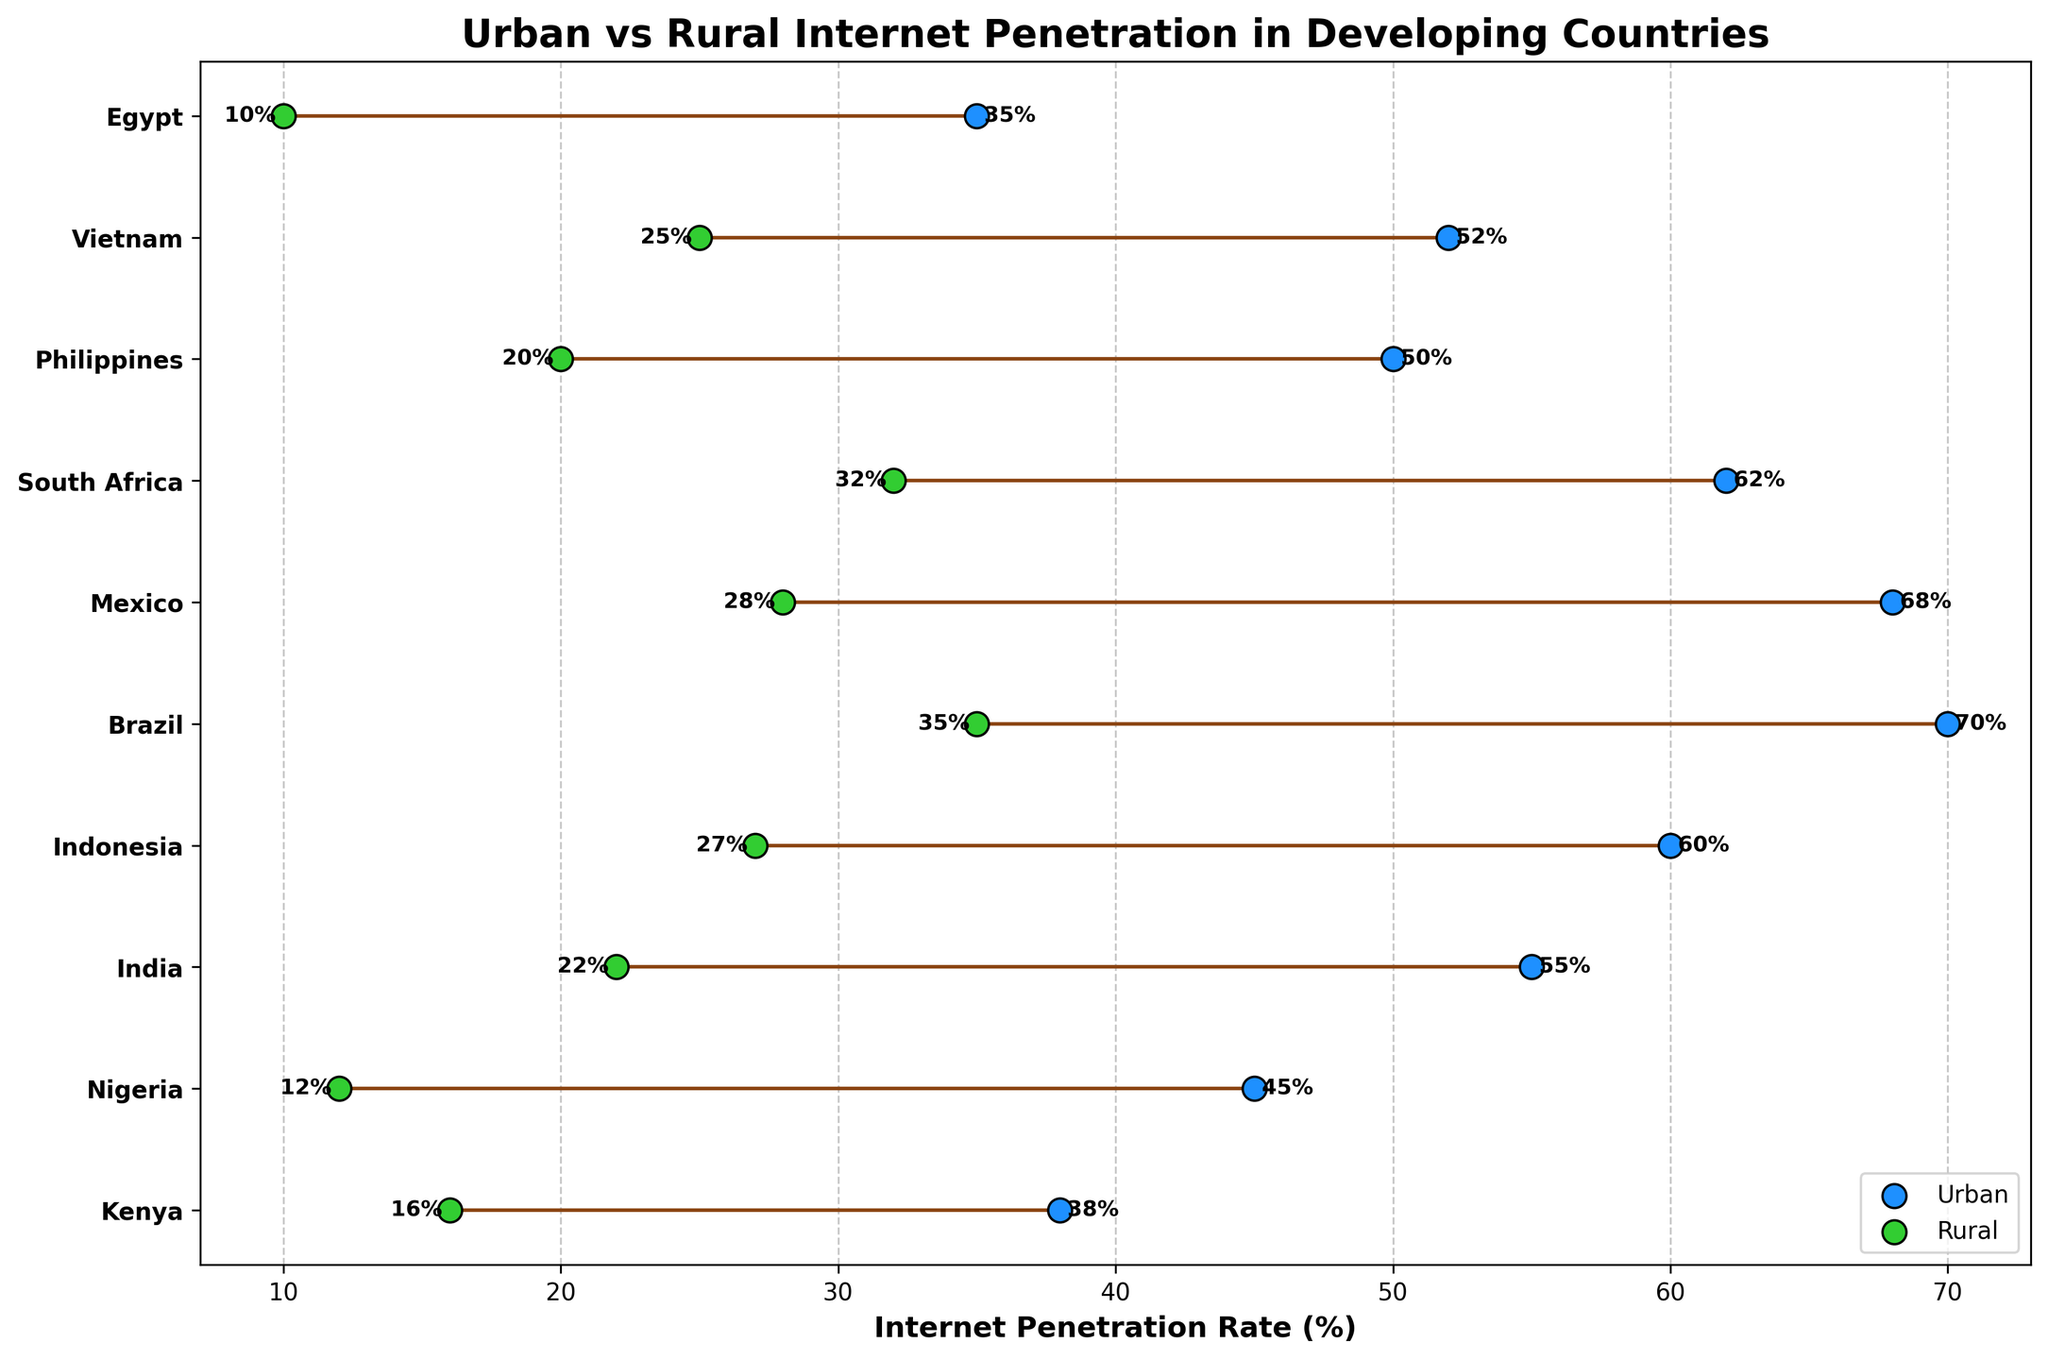What's the title of the figure? The title of a figure is usually at the top and summarizes the content of the plot. Here, the title specifies the comparison between urban and rural internet penetration in developing countries.
Answer: Urban vs Rural Internet Penetration in Developing Countries How many countries are included in the figure? The number of countries can be found by counting the unique y-ticks or labels on the y-axis, which correspond to the countries listed.
Answer: 10 Which country has the highest urban internet penetration rate? By comparing the urban internet penetration rates along the x-axis for all countries, the country with the highest rate will be the one furthest to the right.
Answer: Brazil What is the rural internet penetration rate in Kenya? This can be found by locating Kenya on the y-axis and checking the associated rural rate on the x-axis.
Answer: 16% Which country shows the largest difference between urban and rural internet penetration rates? To determine this, calculate the difference (urban rate - rural rate) for each country and find the maximum value.
Answer: Brazil Which two countries have the smallest gap in internet penetration rates between urban and rural areas? Calculate the difference between urban and rural rates for each country and identify the two smallest differences.
Answer: Kenya and Philippines What is the internet penetration rate in rural regions of Egypt? By locating Egypt on the y-axis and identifying the rural rate on the x-axis, the specific value can be determined.
Answer: 10% Compare the urban internet penetration rates of India and Indonesia. Which is higher? Comparing the urban internet penetration rates of the two countries along the x-axis reveals which rate is higher.
Answer: Indonesia What's the average urban internet penetration rate across all countries? Sum the urban penetration rates of all countries and divide by the number of countries (10) to obtain the average rate.
Answer: 53.5% What color represents the urban internet penetration points on the plot? By observing the colors used for the data points, we can identify how the urban points are represented visually.
Answer: Blue 